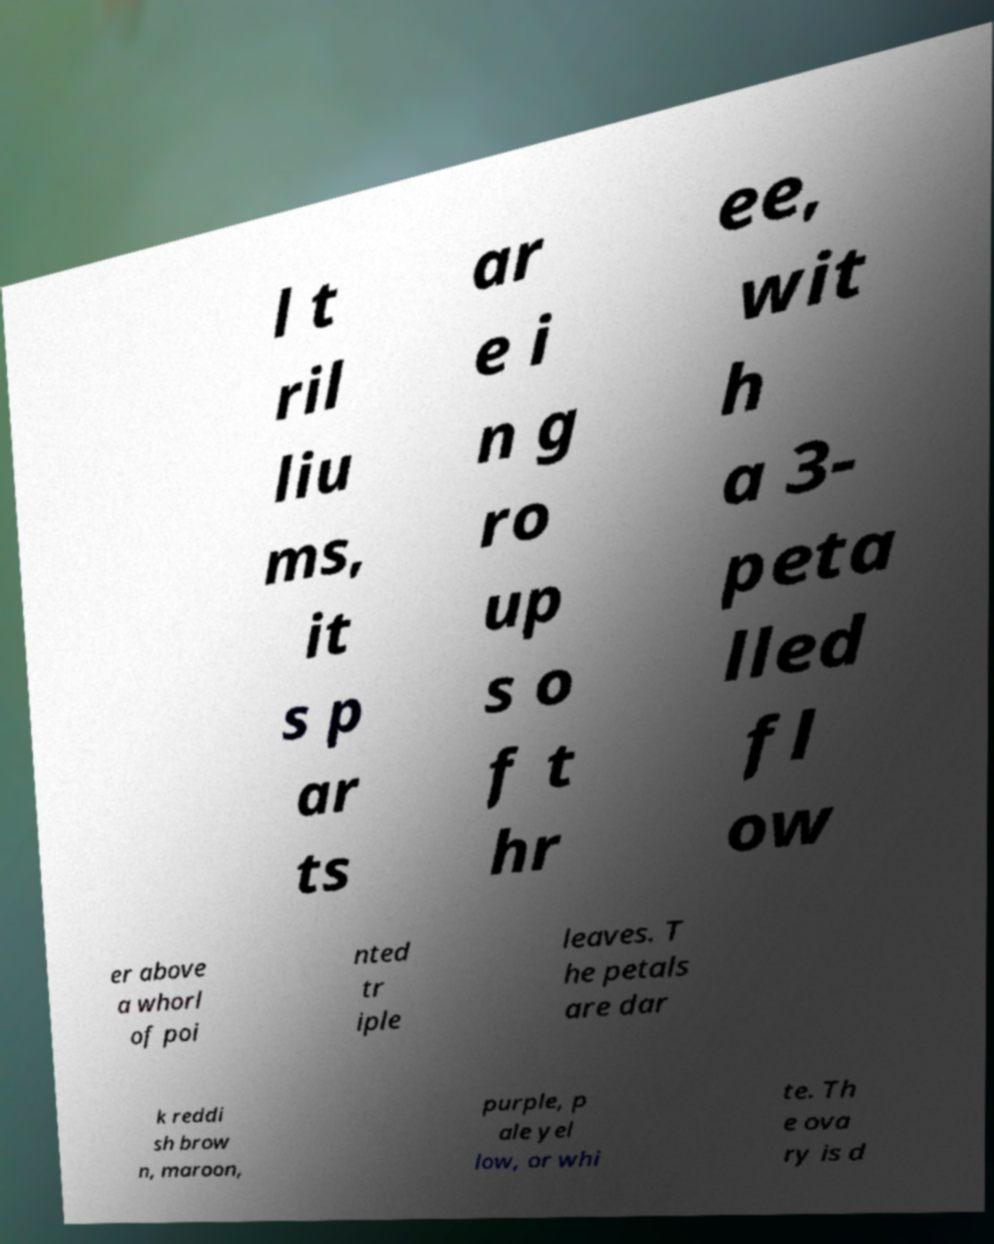Please read and relay the text visible in this image. What does it say? l t ril liu ms, it s p ar ts ar e i n g ro up s o f t hr ee, wit h a 3- peta lled fl ow er above a whorl of poi nted tr iple leaves. T he petals are dar k reddi sh brow n, maroon, purple, p ale yel low, or whi te. Th e ova ry is d 